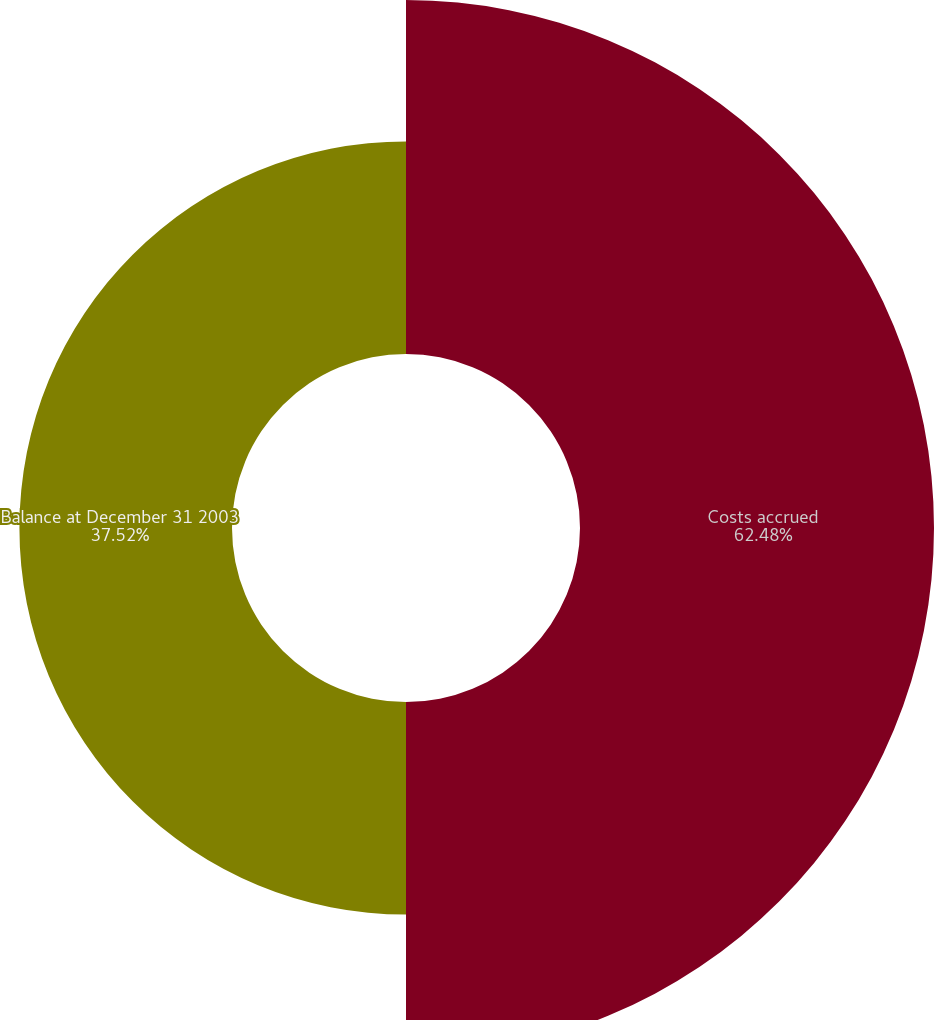Convert chart. <chart><loc_0><loc_0><loc_500><loc_500><pie_chart><fcel>Costs accrued<fcel>Balance at December 31 2003<nl><fcel>62.48%<fcel>37.52%<nl></chart> 